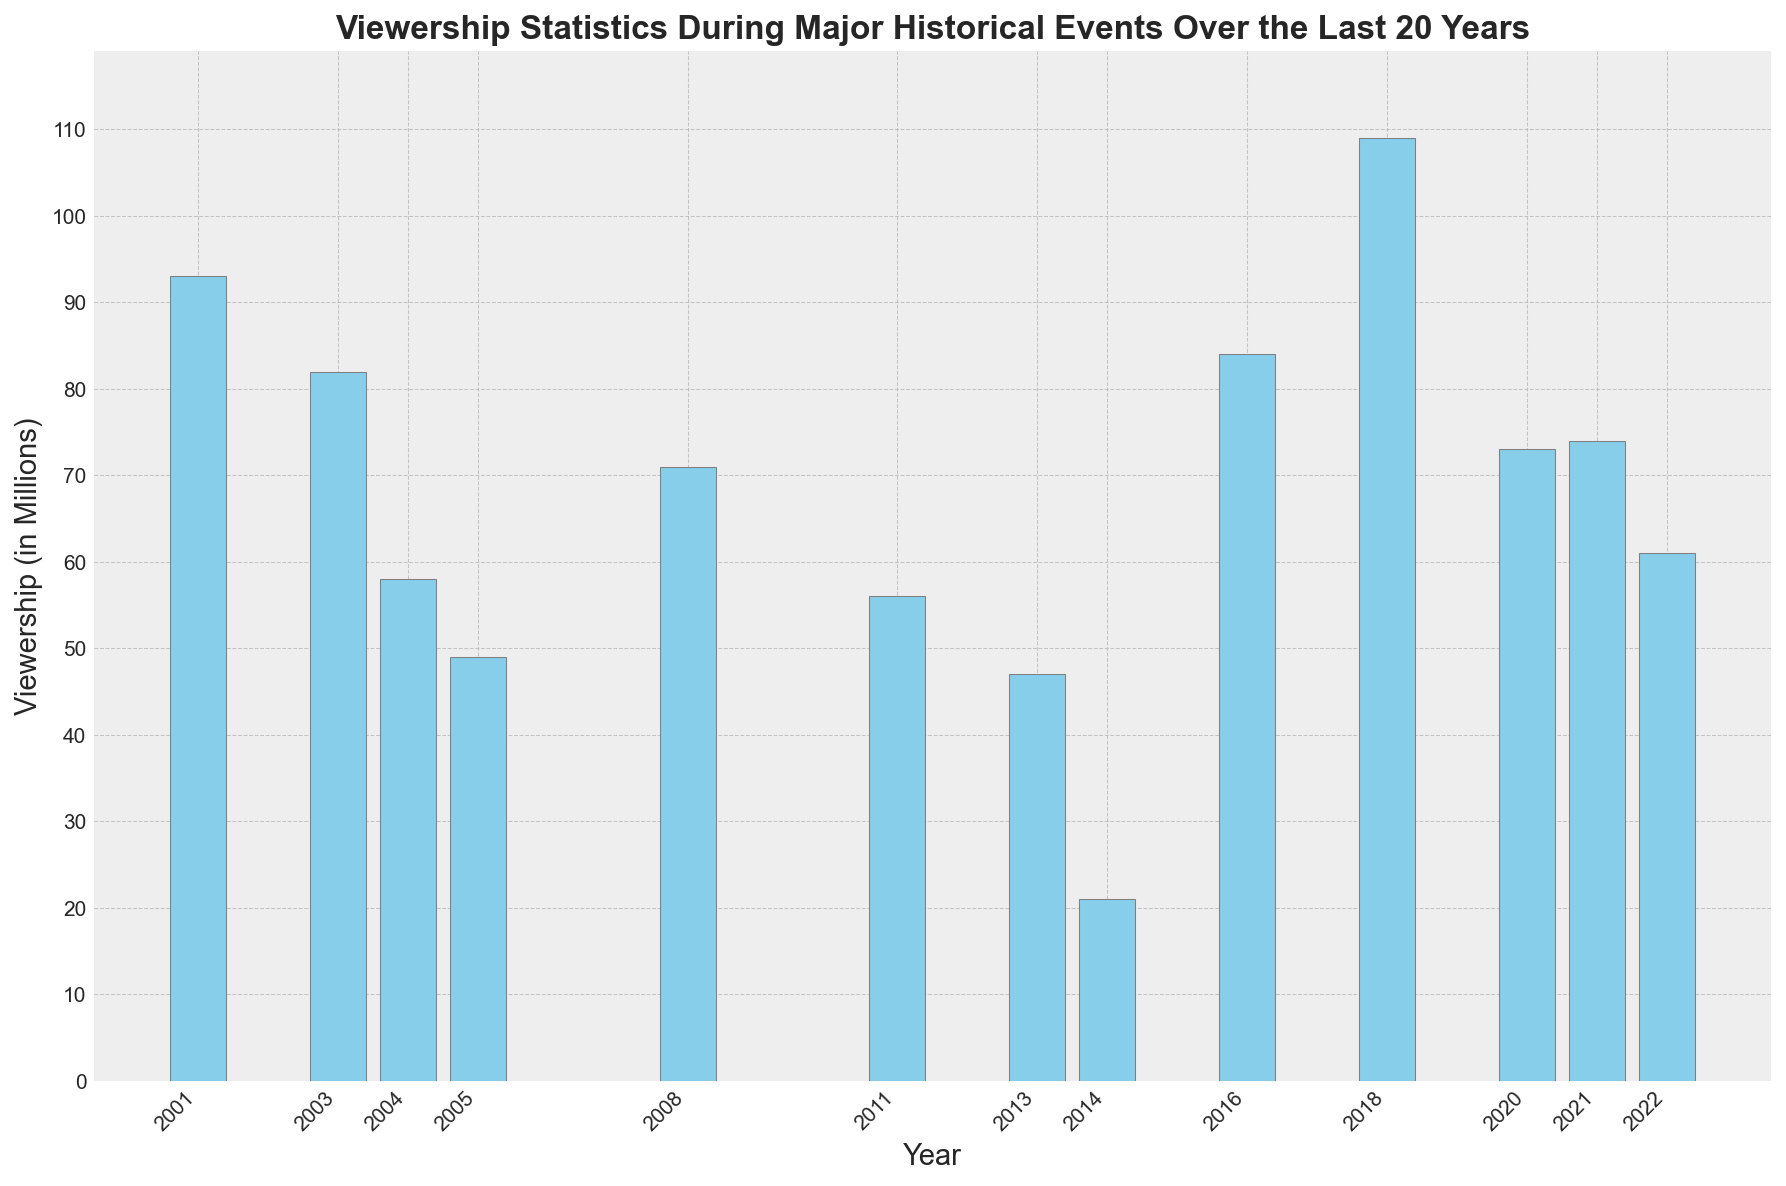What event in the data had the highest viewership? In the plot, look for the tallest bar which represents the highest viewership in millions.
Answer: FIFA World Cup Final 2018 What is the difference in viewership between the 9/11 Attacks and the Boston Marathon Bombing? Identify the bars for the 9/11 Attacks and the Boston Marathon Bombing. Subtract the height of the Boston Marathon Bombing bar from the 9/11 Attacks bar.
Answer: 46 million Which event had a lower viewership: Hurricane Katrina or the Ebola Outbreak? Compare the heights of the bars for Hurricane Katrina and the Ebola Outbreak. The bar with the shorter height indicates lower viewership.
Answer: Ebola Outbreak What is the combined viewership for the Osama Bin Laden Death and the Russia-Ukraine War Invasion? Locate the bars for both events and sum their heights. Osama Bin Laden Death has 56 million, and Russia-Ukraine War Invasion has 61 million.
Answer: 117 million Which event had a higher viewership: the US Presidential Election 2016 or the Obama Election Night 2008? Compare the heights of the bars for the US Presidential Election 2016 and the Obama Election Night 2008. The taller bar indicates higher viewership.
Answer: US Presidential Election 2016 What is the average viewership of the events listed from 2011 to 2022? Identify the bars for the years 2011 to 2022. Find the viewership for each (56, 47, 21, 84, 109, 73, 74, 61), sum them (525) and then divide by the number of events (8).
Answer: 65.625 million How does the viewership for the COVID-19 Pandemic Lockdown compare to the viewership for the US Capitol Insurrection? Compare the heights of the bars for these two events. COVID-19 Pandemic Lockdown has 73 million, and US Capitol Insurrection has 74 million, so the latter is slightly higher.
Answer: US Capitol Insurrection is slightly higher What is the median viewership of all the events listed? List all the viewership figures in ascending order: 21, 47, 49, 56, 58, 61, 71, 73, 74, 82, 84, 93, 109. The middle value of this ordered list is the median.
Answer: 71 million Which year had the lowest viewership, and what was the event? Locate the shortest bar in the plot to find the lowest viewership and identify the corresponding year and event.
Answer: 2014, Ebola Outbreak How many events had viewerships greater than 70 million? Count the number of bars that reach a height above 70 million. These are: 9/11 Attacks (93), FIFA World Cup Final (109), US Presidential Election (84), US Capitol Insurrection (74), Obama Election Night (71), COVID-19 Pandemic Lockdown (73).
Answer: 6 